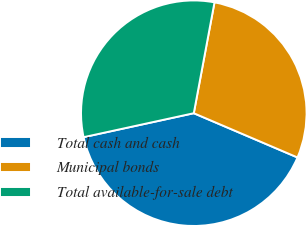<chart> <loc_0><loc_0><loc_500><loc_500><pie_chart><fcel>Total cash and cash<fcel>Municipal bonds<fcel>Total available-for-sale debt<nl><fcel>40.17%<fcel>28.48%<fcel>31.35%<nl></chart> 